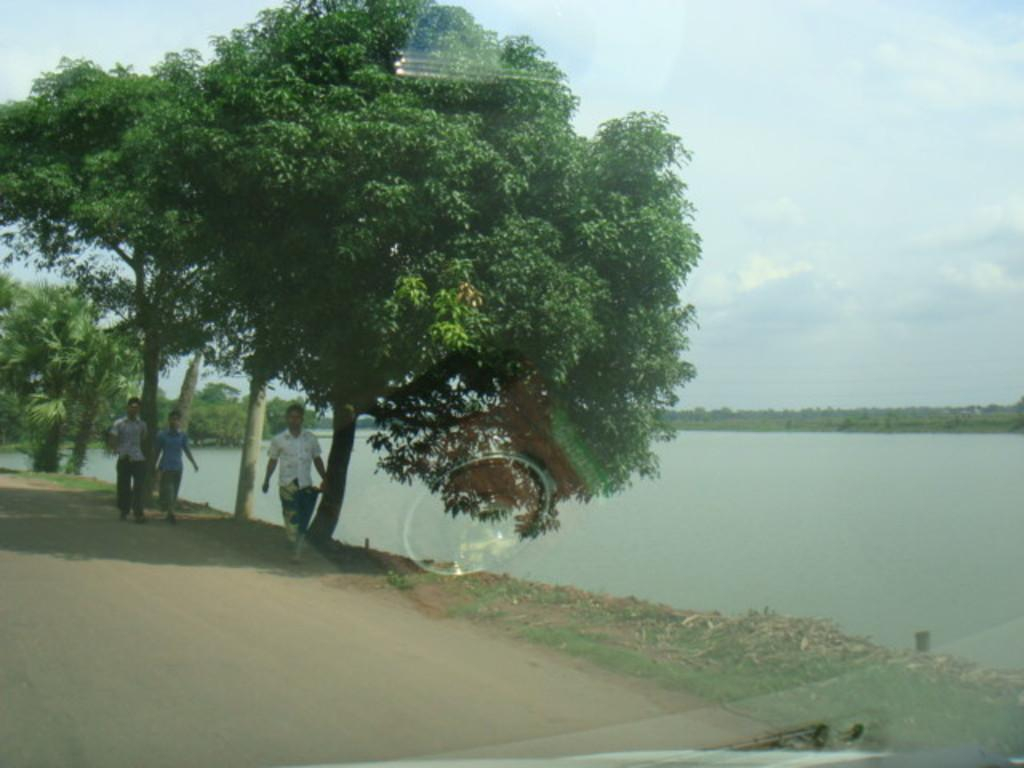What are the people in the image doing? The people in the image are walking. What type of natural environment can be seen in the image? There are trees and water visible in the image. What is the condition of the sky in the image? The sky appears to be cloudy in the image. Can you describe the surface through which the image might have been taken? The image might have been taken through a glass surface. What type of horn can be seen on the pot in the image? There is no pot or horn present in the image. What is the cause of death for the person in the image? There is no person or indication of death in the image. 